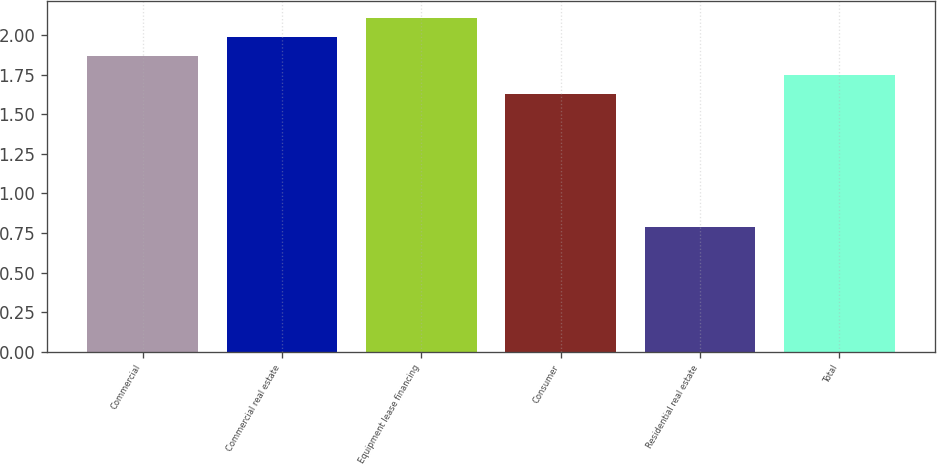Convert chart. <chart><loc_0><loc_0><loc_500><loc_500><bar_chart><fcel>Commercial<fcel>Commercial real estate<fcel>Equipment lease financing<fcel>Consumer<fcel>Residential real estate<fcel>Total<nl><fcel>1.87<fcel>1.99<fcel>2.11<fcel>1.63<fcel>0.79<fcel>1.75<nl></chart> 